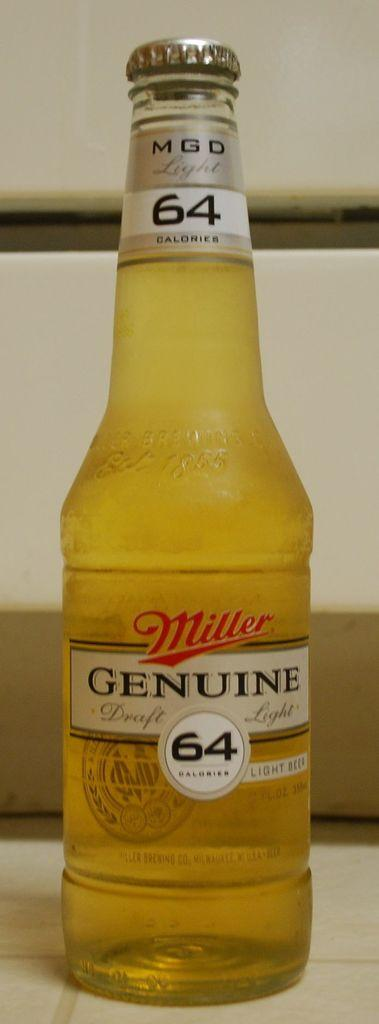What object can be seen on the ground in the image? There is a bottle on the ground in the image. What is unique about the bottle's appearance? The bottle has a label on it. Is there anything that might be used to open or close the bottle? Yes, there is a lid on the bottle. What type of cast can be seen on the person's arm in the image? There is no person or cast present in the image; it only features a bottle on the ground. How does the love between the two characters in the image manifest itself? There are no characters or love depicted in the image; it only features a bottle on the ground. 